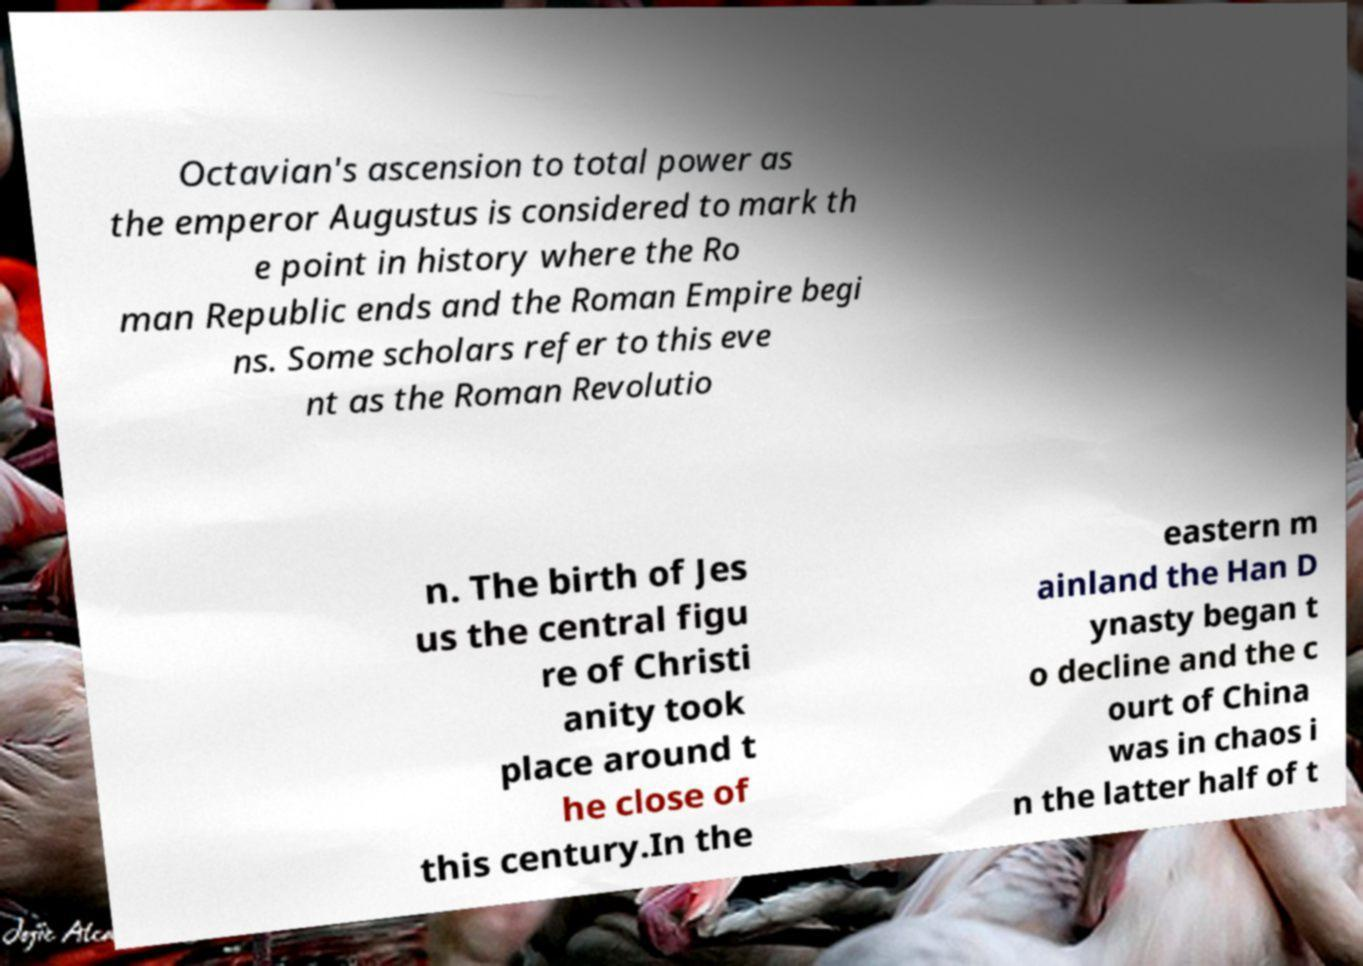There's text embedded in this image that I need extracted. Can you transcribe it verbatim? Octavian's ascension to total power as the emperor Augustus is considered to mark th e point in history where the Ro man Republic ends and the Roman Empire begi ns. Some scholars refer to this eve nt as the Roman Revolutio n. The birth of Jes us the central figu re of Christi anity took place around t he close of this century.In the eastern m ainland the Han D ynasty began t o decline and the c ourt of China was in chaos i n the latter half of t 